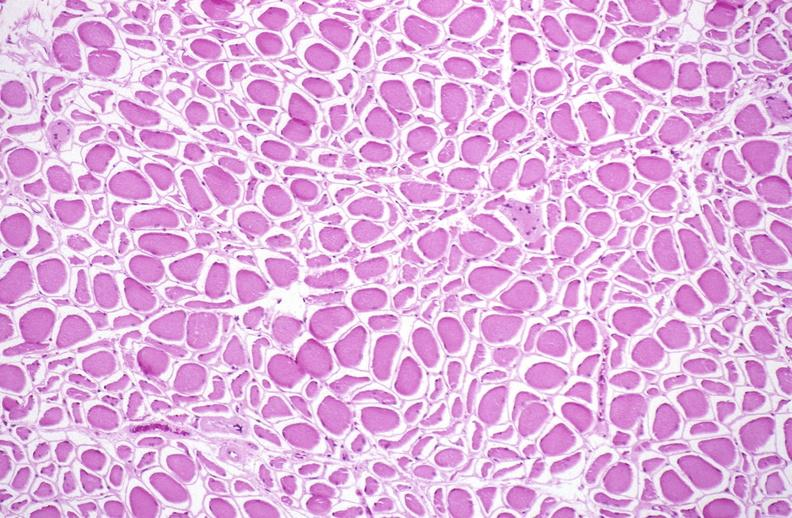what is present?
Answer the question using a single word or phrase. Soft tissue 